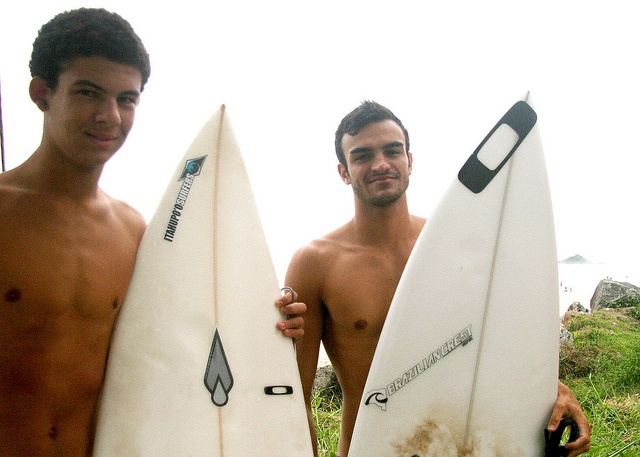Describe the objects in this image and their specific colors. I can see surfboard in white, lightgray, and tan tones, people in white, maroon, black, and brown tones, surfboard in white, lightgray, tan, and darkgray tones, and people in white, gray, maroon, and brown tones in this image. 